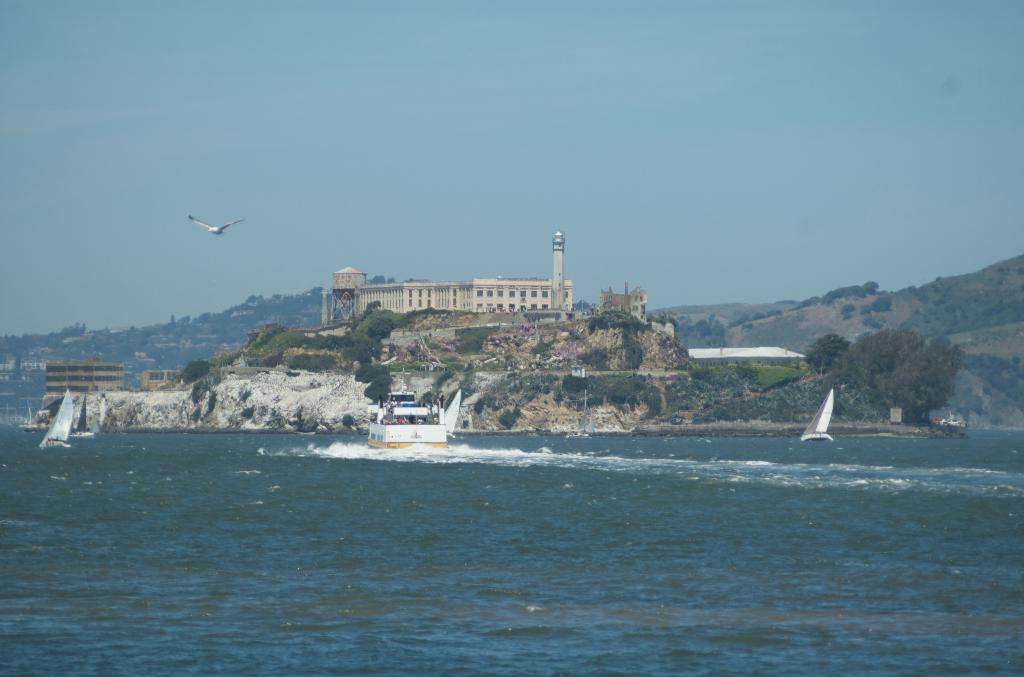What type of vehicles are in the water in the image? There are ships in the water in the image. What type of vehicle is in the air in the image? There is an airplane in the air in the image. What structures can be seen in the background of the image? There are buildings, trees, and mountains in the background of the image. What part of the natural environment is visible in the image? The sky is visible in the background of the image. How many pigs are visible on the board in the image? There are no pigs or boards present in the image. What type of arithmetic problem is being solved on the mountain in the image? There is no arithmetic problem being solved in the image; it features ships, an airplane, and various background elements. 